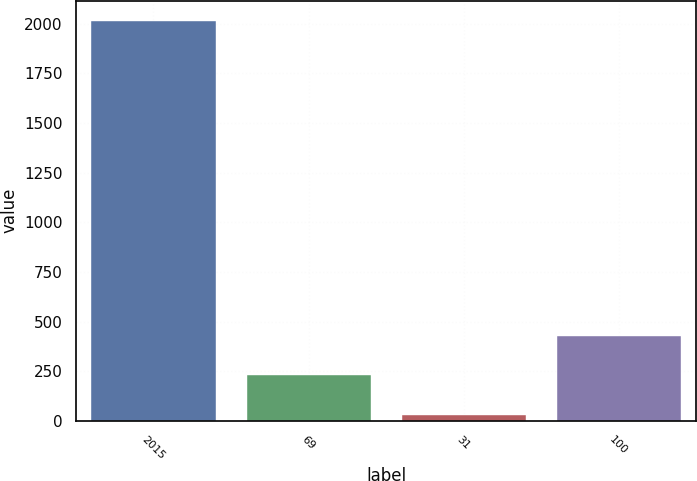Convert chart to OTSL. <chart><loc_0><loc_0><loc_500><loc_500><bar_chart><fcel>2015<fcel>69<fcel>31<fcel>100<nl><fcel>2015<fcel>229.4<fcel>31<fcel>427.8<nl></chart> 